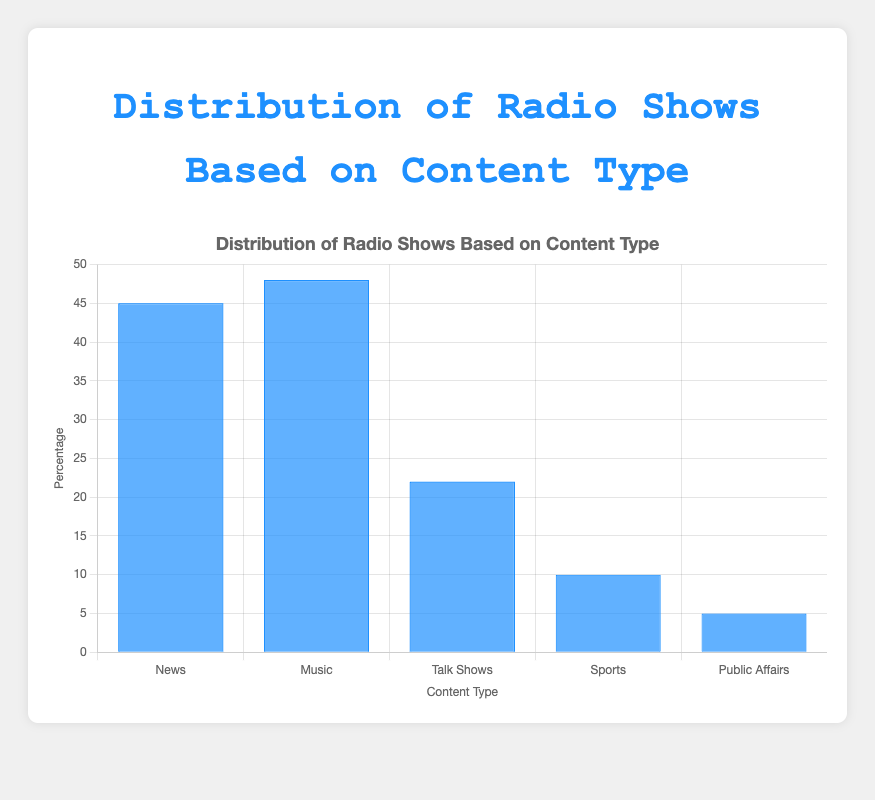What's the most prominent content type in terms of percentage? The chart shows multiple content types with their respective percentages. By comparing the heights of all bars, the music category is the highest
Answer: Music How does the total percentage of news programs compare to talk shows? The news programs have a combined percentage (20 + 15 + 10) = 45%, and talk shows have a combined percentage (10 + 5 + 7) = 22%. So, news has a higher total percentage than talk shows
Answer: News is higher Which content type has the smallest overall percentage, and what's the value? Looking at the chart, the Public Affairs category has the smallest bar. By summing its programs' percentages (2 + 2 + 1) = 5%
Answer: Public Affairs with 5% What's the difference in percentage between the highest and the lowest content type? The highest content type is Music at 48% and the lowest is Public Affairs at 5%. The difference is 48% - 5% = 43%
Answer: 43% What is the sum of the percentages for sports and public affairs combined? For sports, add up (5 + 3 + 2) = 10%. For public affairs, add up (2 + 2 + 1) = 5%. The total is 10% + 5% = 15%
Answer: 15% Which content type represents exactly 25% of the total, and how is it visually confirmed on the chart? The Music category is at 25%, visually confirmed as its bar height is distinctly higher than most yet lower than the highest bars
Answer: Music What fraction of the total radio show distribution do talk shows represent? The total is the sum of all content types' percentages: 45 (News) + 48 (Music) + 22 (Talk Shows) + 10 (Sports) + 5 (Public Affairs) = 130%. The fraction for talk shows is 22/130
Answer: Approximately 1/6 What's the percentage difference between the news programs and the music programs? News programs have 45%, and music programs have 48%. The difference is 48% - 45% = 3%
Answer: 3% Arrange the content types in descending order of their overall percentages. Reviewing the bar heights and summing the percentages for each content type gives: Music (48%), News (45%), Talk Shows (22%), Sports (10%), Public Affairs (5%)
Answer: Music, News, Talk Shows, Sports, Public Affairs What is the average percentage of all the content types? The sum of all percentages is 130%. There are 5 content types. The average is 130/5
Answer: 26% 